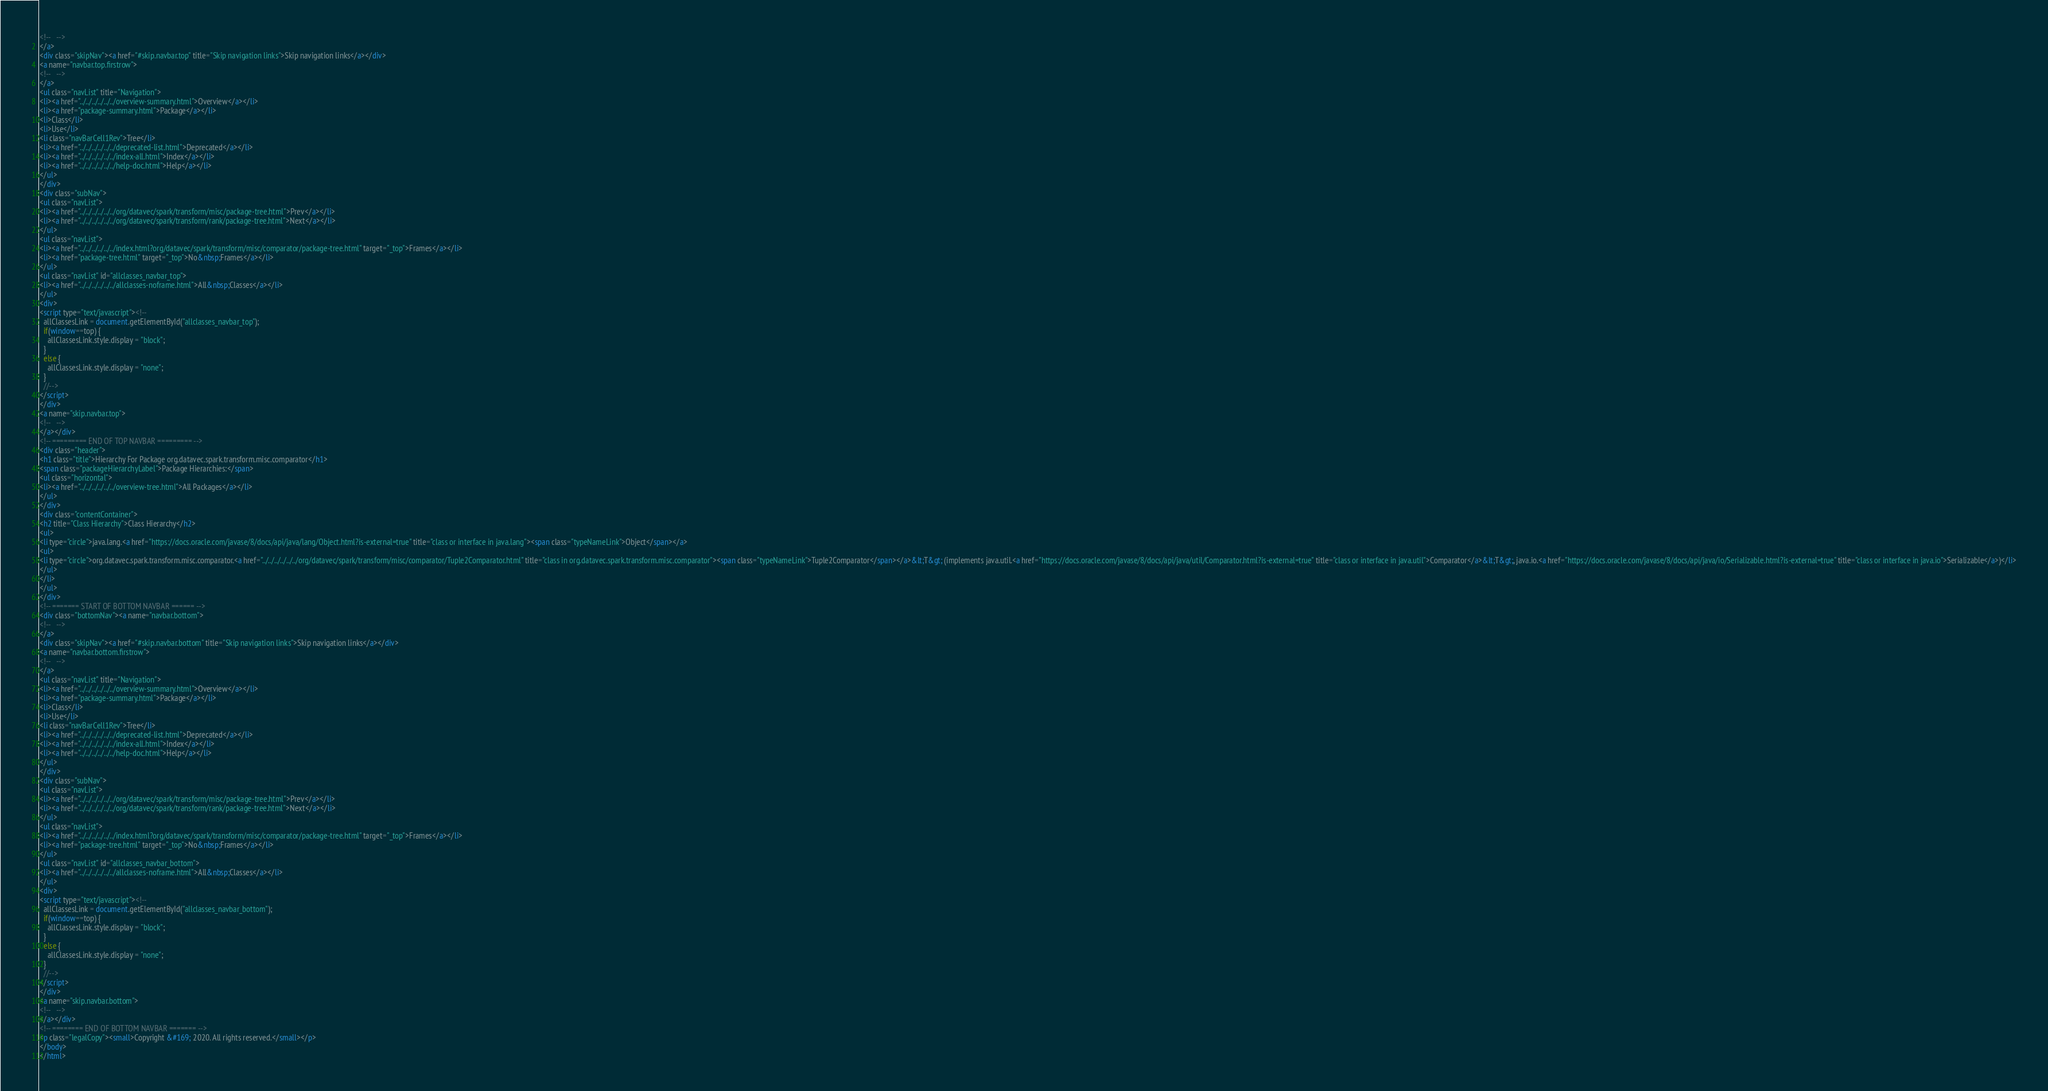<code> <loc_0><loc_0><loc_500><loc_500><_HTML_><!--   -->
</a>
<div class="skipNav"><a href="#skip.navbar.top" title="Skip navigation links">Skip navigation links</a></div>
<a name="navbar.top.firstrow">
<!--   -->
</a>
<ul class="navList" title="Navigation">
<li><a href="../../../../../../overview-summary.html">Overview</a></li>
<li><a href="package-summary.html">Package</a></li>
<li>Class</li>
<li>Use</li>
<li class="navBarCell1Rev">Tree</li>
<li><a href="../../../../../../deprecated-list.html">Deprecated</a></li>
<li><a href="../../../../../../index-all.html">Index</a></li>
<li><a href="../../../../../../help-doc.html">Help</a></li>
</ul>
</div>
<div class="subNav">
<ul class="navList">
<li><a href="../../../../../../org/datavec/spark/transform/misc/package-tree.html">Prev</a></li>
<li><a href="../../../../../../org/datavec/spark/transform/rank/package-tree.html">Next</a></li>
</ul>
<ul class="navList">
<li><a href="../../../../../../index.html?org/datavec/spark/transform/misc/comparator/package-tree.html" target="_top">Frames</a></li>
<li><a href="package-tree.html" target="_top">No&nbsp;Frames</a></li>
</ul>
<ul class="navList" id="allclasses_navbar_top">
<li><a href="../../../../../../allclasses-noframe.html">All&nbsp;Classes</a></li>
</ul>
<div>
<script type="text/javascript"><!--
  allClassesLink = document.getElementById("allclasses_navbar_top");
  if(window==top) {
    allClassesLink.style.display = "block";
  }
  else {
    allClassesLink.style.display = "none";
  }
  //-->
</script>
</div>
<a name="skip.navbar.top">
<!--   -->
</a></div>
<!-- ========= END OF TOP NAVBAR ========= -->
<div class="header">
<h1 class="title">Hierarchy For Package org.datavec.spark.transform.misc.comparator</h1>
<span class="packageHierarchyLabel">Package Hierarchies:</span>
<ul class="horizontal">
<li><a href="../../../../../../overview-tree.html">All Packages</a></li>
</ul>
</div>
<div class="contentContainer">
<h2 title="Class Hierarchy">Class Hierarchy</h2>
<ul>
<li type="circle">java.lang.<a href="https://docs.oracle.com/javase/8/docs/api/java/lang/Object.html?is-external=true" title="class or interface in java.lang"><span class="typeNameLink">Object</span></a>
<ul>
<li type="circle">org.datavec.spark.transform.misc.comparator.<a href="../../../../../../org/datavec/spark/transform/misc/comparator/Tuple2Comparator.html" title="class in org.datavec.spark.transform.misc.comparator"><span class="typeNameLink">Tuple2Comparator</span></a>&lt;T&gt; (implements java.util.<a href="https://docs.oracle.com/javase/8/docs/api/java/util/Comparator.html?is-external=true" title="class or interface in java.util">Comparator</a>&lt;T&gt;, java.io.<a href="https://docs.oracle.com/javase/8/docs/api/java/io/Serializable.html?is-external=true" title="class or interface in java.io">Serializable</a>)</li>
</ul>
</li>
</ul>
</div>
<!-- ======= START OF BOTTOM NAVBAR ====== -->
<div class="bottomNav"><a name="navbar.bottom">
<!--   -->
</a>
<div class="skipNav"><a href="#skip.navbar.bottom" title="Skip navigation links">Skip navigation links</a></div>
<a name="navbar.bottom.firstrow">
<!--   -->
</a>
<ul class="navList" title="Navigation">
<li><a href="../../../../../../overview-summary.html">Overview</a></li>
<li><a href="package-summary.html">Package</a></li>
<li>Class</li>
<li>Use</li>
<li class="navBarCell1Rev">Tree</li>
<li><a href="../../../../../../deprecated-list.html">Deprecated</a></li>
<li><a href="../../../../../../index-all.html">Index</a></li>
<li><a href="../../../../../../help-doc.html">Help</a></li>
</ul>
</div>
<div class="subNav">
<ul class="navList">
<li><a href="../../../../../../org/datavec/spark/transform/misc/package-tree.html">Prev</a></li>
<li><a href="../../../../../../org/datavec/spark/transform/rank/package-tree.html">Next</a></li>
</ul>
<ul class="navList">
<li><a href="../../../../../../index.html?org/datavec/spark/transform/misc/comparator/package-tree.html" target="_top">Frames</a></li>
<li><a href="package-tree.html" target="_top">No&nbsp;Frames</a></li>
</ul>
<ul class="navList" id="allclasses_navbar_bottom">
<li><a href="../../../../../../allclasses-noframe.html">All&nbsp;Classes</a></li>
</ul>
<div>
<script type="text/javascript"><!--
  allClassesLink = document.getElementById("allclasses_navbar_bottom");
  if(window==top) {
    allClassesLink.style.display = "block";
  }
  else {
    allClassesLink.style.display = "none";
  }
  //-->
</script>
</div>
<a name="skip.navbar.bottom">
<!--   -->
</a></div>
<!-- ======== END OF BOTTOM NAVBAR ======= -->
<p class="legalCopy"><small>Copyright &#169; 2020. All rights reserved.</small></p>
</body>
</html>
</code> 